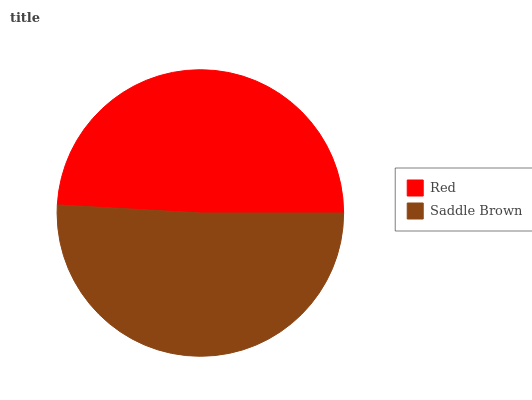Is Red the minimum?
Answer yes or no. Yes. Is Saddle Brown the maximum?
Answer yes or no. Yes. Is Saddle Brown the minimum?
Answer yes or no. No. Is Saddle Brown greater than Red?
Answer yes or no. Yes. Is Red less than Saddle Brown?
Answer yes or no. Yes. Is Red greater than Saddle Brown?
Answer yes or no. No. Is Saddle Brown less than Red?
Answer yes or no. No. Is Saddle Brown the high median?
Answer yes or no. Yes. Is Red the low median?
Answer yes or no. Yes. Is Red the high median?
Answer yes or no. No. Is Saddle Brown the low median?
Answer yes or no. No. 